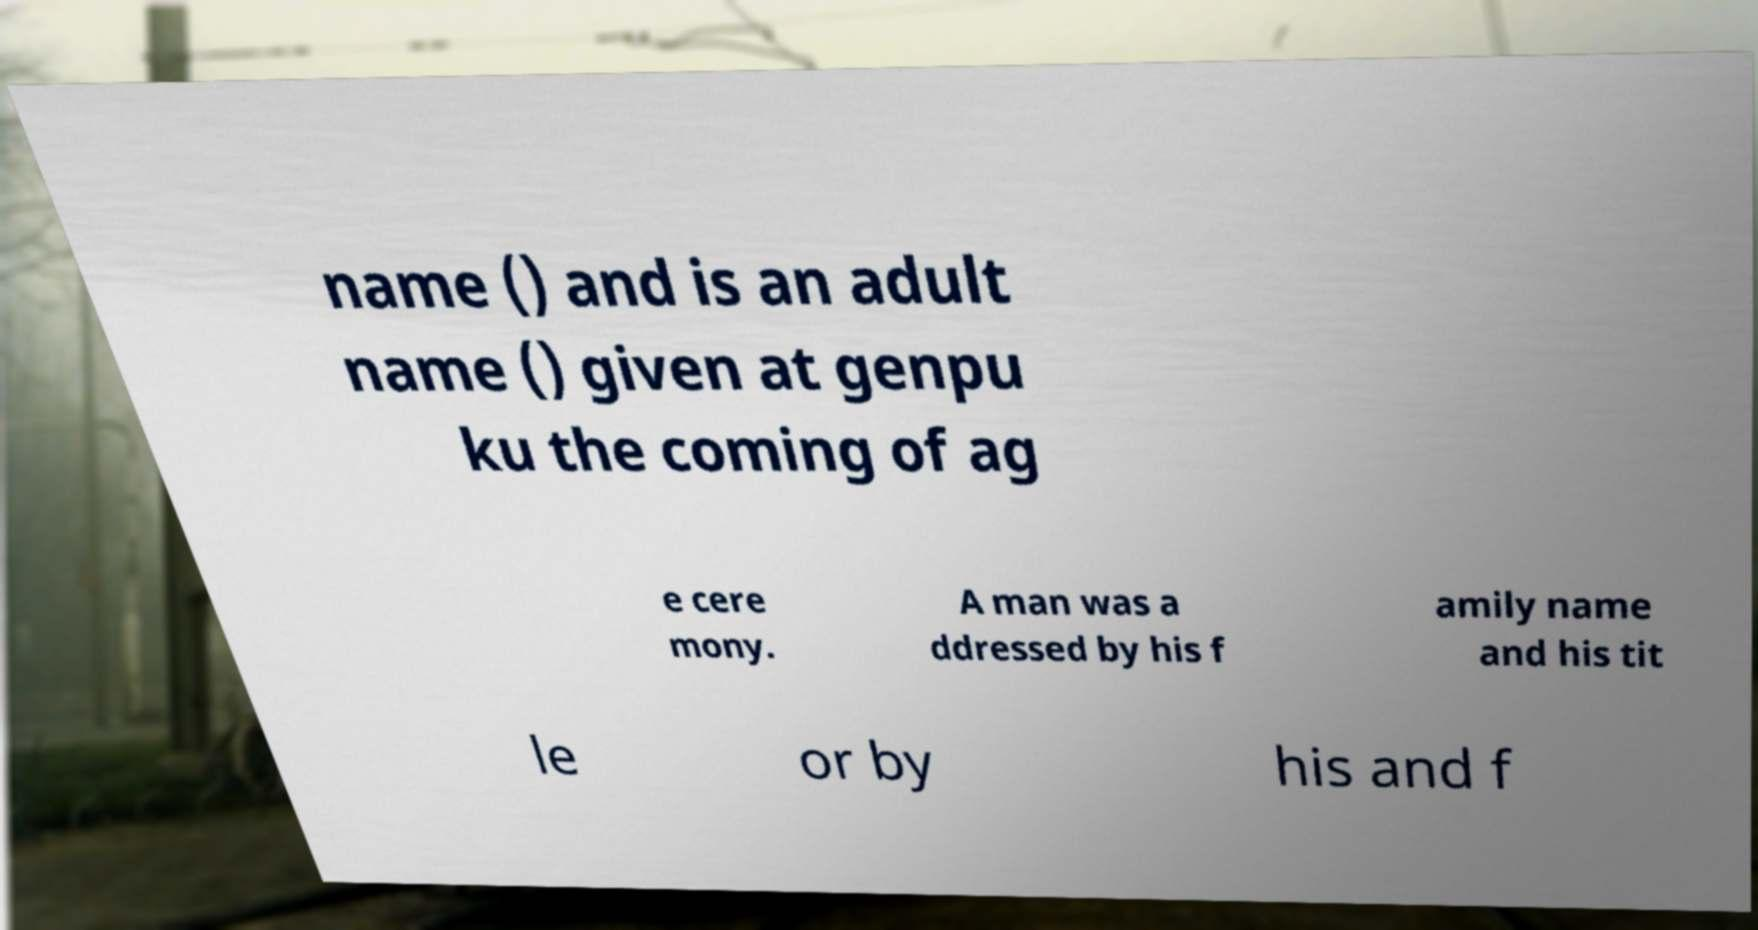Could you extract and type out the text from this image? name () and is an adult name () given at genpu ku the coming of ag e cere mony. A man was a ddressed by his f amily name and his tit le or by his and f 